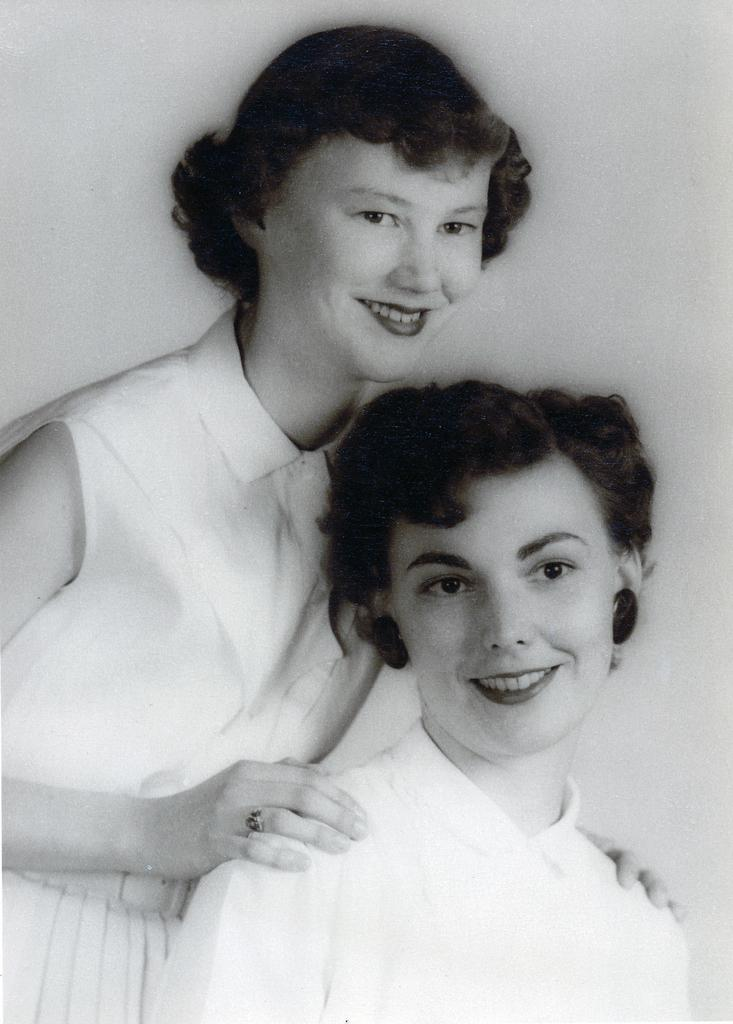What is the color scheme of the image? The image is black and white. How many women are present in the image? There are two women in the image. What expression do the women have in the image? The women are smiling in the image. What type of chalk is the fireman using to draw humor in the image? There is no fireman or chalk present in the image, and therefore no such activity can be observed. 